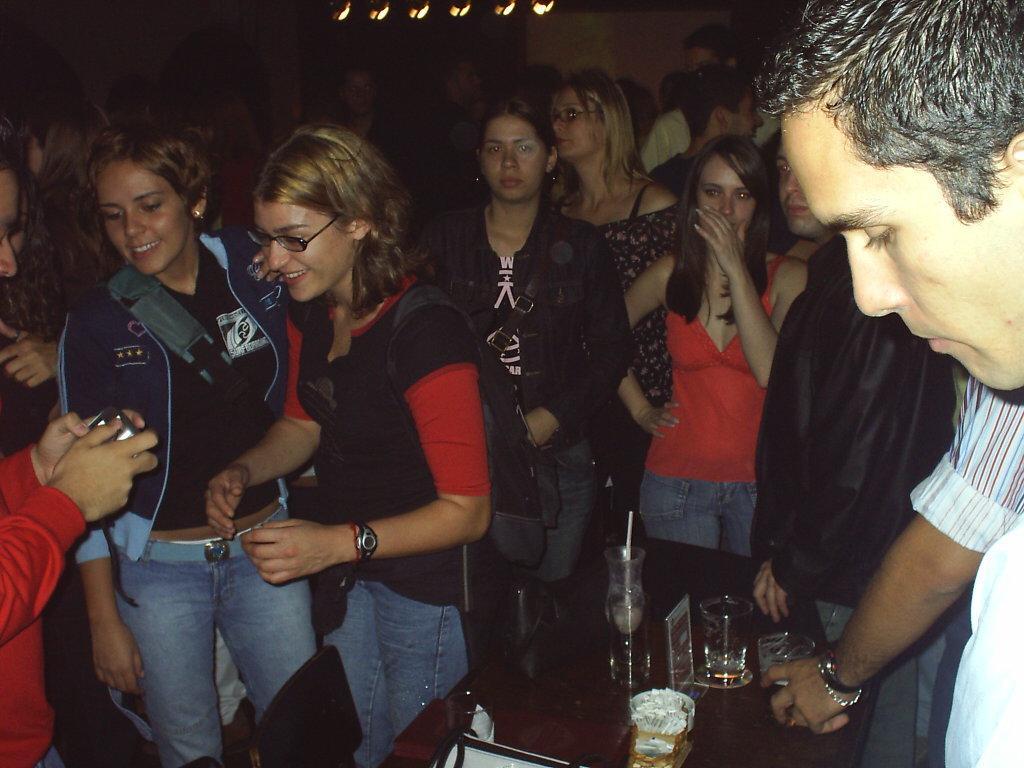Could you give a brief overview of what you see in this image? In this picture there is a girl who is wearing spectacle, t-shirt, watch and jeans. she is looking to the camera who is holding by man. On the right there is a man who is standing near to the table. Here we can see group of persons. On the table we can see wine glass, wine bottle, poster and other object. On the top we can see lights. 